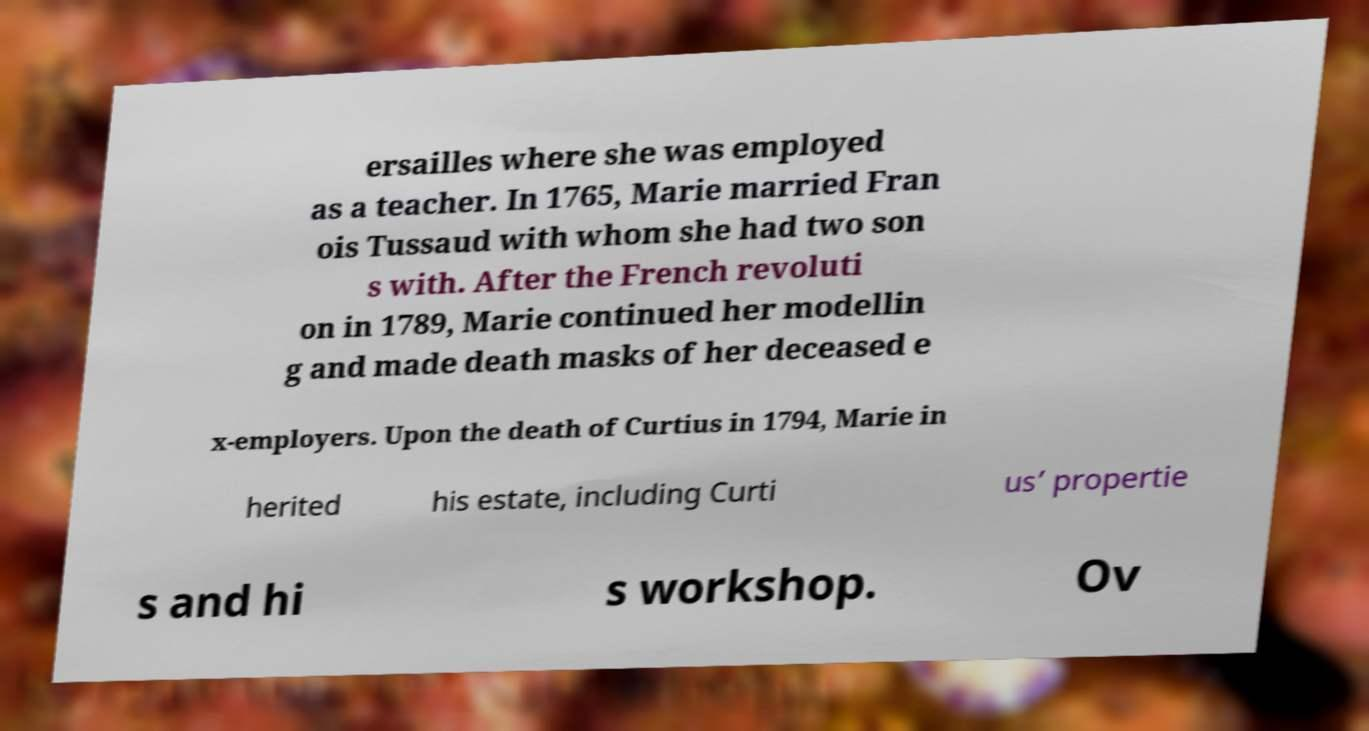There's text embedded in this image that I need extracted. Can you transcribe it verbatim? ersailles where she was employed as a teacher. In 1765, Marie married Fran ois Tussaud with whom she had two son s with. After the French revoluti on in 1789, Marie continued her modellin g and made death masks of her deceased e x-employers. Upon the death of Curtius in 1794, Marie in herited his estate, including Curti us’ propertie s and hi s workshop. Ov 